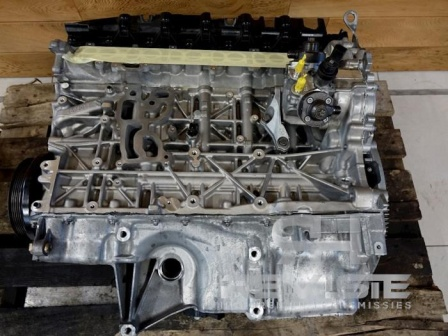What kind of maintenance might this engine block be undergoing? The engine block might be undergoing several types of maintenance or repair activities. Common procedures include inspecting for cracks or damages, cleaning and resurfacing the block, replacing gaskets, and checking and replacing any worn-out components. Additionally, technicians might be performing pressure tests to ensure there are no leaks and that the engine block maintains proper sealing. What could be the reason for the engine block being removed from the vehicle? There are multiple reasons why an engine block might be removed from a vehicle. Common causes include significant damage, such as cracks or warping, which might require machining or replacement. Other reasons could involve upgrading the engine components for better performance, rebuilding the engine to restore it to factory specifications, or performing extensive cleaning and maintenance that can't be completed while the engine is installed. 